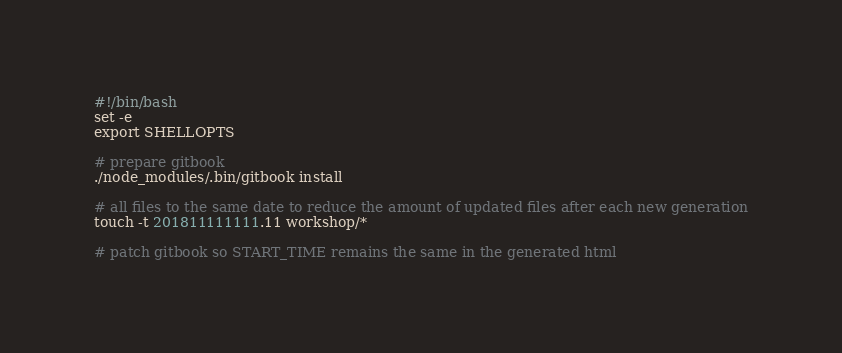Convert code to text. <code><loc_0><loc_0><loc_500><loc_500><_Bash_>#!/bin/bash
set -e
export SHELLOPTS

# prepare gitbook
./node_modules/.bin/gitbook install

# all files to the same date to reduce the amount of updated files after each new generation
touch -t 201811111111.11 workshop/*

# patch gitbook so START_TIME remains the same in the generated html</code> 